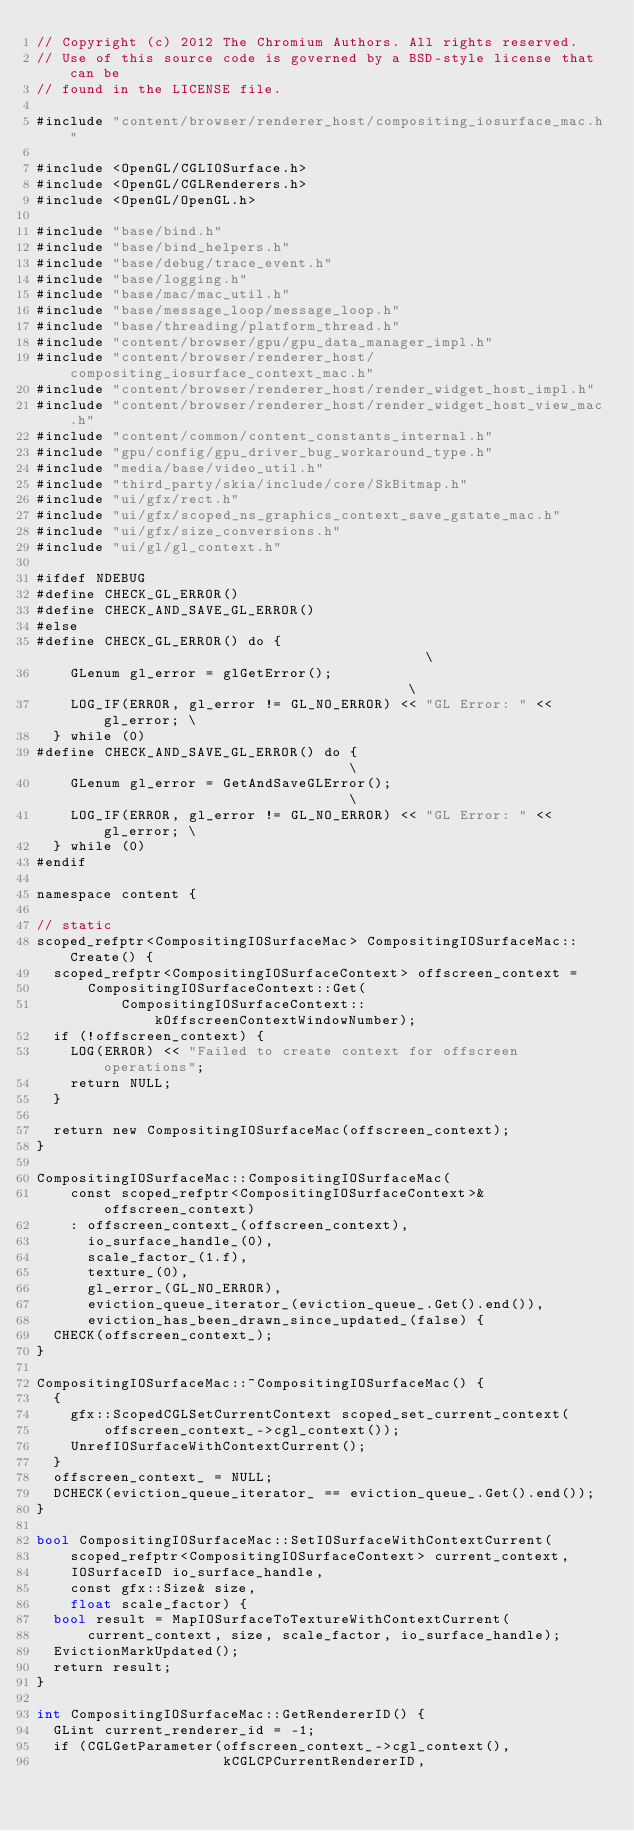Convert code to text. <code><loc_0><loc_0><loc_500><loc_500><_ObjectiveC_>// Copyright (c) 2012 The Chromium Authors. All rights reserved.
// Use of this source code is governed by a BSD-style license that can be
// found in the LICENSE file.

#include "content/browser/renderer_host/compositing_iosurface_mac.h"

#include <OpenGL/CGLIOSurface.h>
#include <OpenGL/CGLRenderers.h>
#include <OpenGL/OpenGL.h>

#include "base/bind.h"
#include "base/bind_helpers.h"
#include "base/debug/trace_event.h"
#include "base/logging.h"
#include "base/mac/mac_util.h"
#include "base/message_loop/message_loop.h"
#include "base/threading/platform_thread.h"
#include "content/browser/gpu/gpu_data_manager_impl.h"
#include "content/browser/renderer_host/compositing_iosurface_context_mac.h"
#include "content/browser/renderer_host/render_widget_host_impl.h"
#include "content/browser/renderer_host/render_widget_host_view_mac.h"
#include "content/common/content_constants_internal.h"
#include "gpu/config/gpu_driver_bug_workaround_type.h"
#include "media/base/video_util.h"
#include "third_party/skia/include/core/SkBitmap.h"
#include "ui/gfx/rect.h"
#include "ui/gfx/scoped_ns_graphics_context_save_gstate_mac.h"
#include "ui/gfx/size_conversions.h"
#include "ui/gl/gl_context.h"

#ifdef NDEBUG
#define CHECK_GL_ERROR()
#define CHECK_AND_SAVE_GL_ERROR()
#else
#define CHECK_GL_ERROR() do {                                           \
    GLenum gl_error = glGetError();                                     \
    LOG_IF(ERROR, gl_error != GL_NO_ERROR) << "GL Error: " << gl_error; \
  } while (0)
#define CHECK_AND_SAVE_GL_ERROR() do {                                  \
    GLenum gl_error = GetAndSaveGLError();                              \
    LOG_IF(ERROR, gl_error != GL_NO_ERROR) << "GL Error: " << gl_error; \
  } while (0)
#endif

namespace content {

// static
scoped_refptr<CompositingIOSurfaceMac> CompositingIOSurfaceMac::Create() {
  scoped_refptr<CompositingIOSurfaceContext> offscreen_context =
      CompositingIOSurfaceContext::Get(
          CompositingIOSurfaceContext::kOffscreenContextWindowNumber);
  if (!offscreen_context) {
    LOG(ERROR) << "Failed to create context for offscreen operations";
    return NULL;
  }

  return new CompositingIOSurfaceMac(offscreen_context);
}

CompositingIOSurfaceMac::CompositingIOSurfaceMac(
    const scoped_refptr<CompositingIOSurfaceContext>& offscreen_context)
    : offscreen_context_(offscreen_context),
      io_surface_handle_(0),
      scale_factor_(1.f),
      texture_(0),
      gl_error_(GL_NO_ERROR),
      eviction_queue_iterator_(eviction_queue_.Get().end()),
      eviction_has_been_drawn_since_updated_(false) {
  CHECK(offscreen_context_);
}

CompositingIOSurfaceMac::~CompositingIOSurfaceMac() {
  {
    gfx::ScopedCGLSetCurrentContext scoped_set_current_context(
        offscreen_context_->cgl_context());
    UnrefIOSurfaceWithContextCurrent();
  }
  offscreen_context_ = NULL;
  DCHECK(eviction_queue_iterator_ == eviction_queue_.Get().end());
}

bool CompositingIOSurfaceMac::SetIOSurfaceWithContextCurrent(
    scoped_refptr<CompositingIOSurfaceContext> current_context,
    IOSurfaceID io_surface_handle,
    const gfx::Size& size,
    float scale_factor) {
  bool result = MapIOSurfaceToTextureWithContextCurrent(
      current_context, size, scale_factor, io_surface_handle);
  EvictionMarkUpdated();
  return result;
}

int CompositingIOSurfaceMac::GetRendererID() {
  GLint current_renderer_id = -1;
  if (CGLGetParameter(offscreen_context_->cgl_context(),
                      kCGLCPCurrentRendererID,</code> 